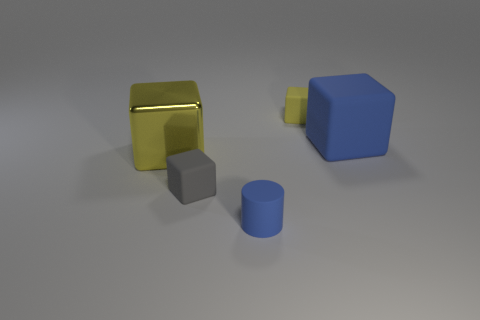Add 2 tiny red metallic cubes. How many objects exist? 7 Subtract all cylinders. How many objects are left? 4 Subtract 1 blocks. How many blocks are left? 3 Subtract all yellow cylinders. Subtract all green spheres. How many cylinders are left? 1 Subtract all brown cubes. How many green cylinders are left? 0 Subtract all large brown metal blocks. Subtract all small blue things. How many objects are left? 4 Add 5 yellow rubber blocks. How many yellow rubber blocks are left? 6 Add 2 big brown cubes. How many big brown cubes exist? 2 Subtract all yellow cubes. How many cubes are left? 2 Subtract all big matte blocks. How many blocks are left? 3 